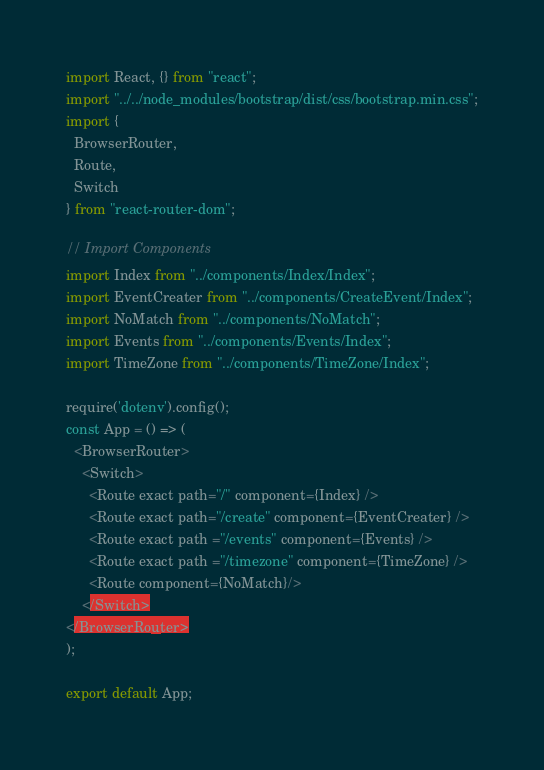<code> <loc_0><loc_0><loc_500><loc_500><_JavaScript_>import React, {} from "react";
import "../../node_modules/bootstrap/dist/css/bootstrap.min.css";
import {
  BrowserRouter,
  Route,
  Switch
} from "react-router-dom";

// Import Components
import Index from "../components/Index/Index";
import EventCreater from "../components/CreateEvent/Index";
import NoMatch from "../components/NoMatch";
import Events from "../components/Events/Index";
import TimeZone from "../components/TimeZone/Index";

require('dotenv').config();
const App = () => (
  <BrowserRouter>
    <Switch>
      <Route exact path="/" component={Index} />
      <Route exact path="/create" component={EventCreater} />
      <Route exact path ="/events" component={Events} />
      <Route exact path ="/timezone" component={TimeZone} />
      <Route component={NoMatch}/>           
    </Switch>
</BrowserRouter>
);

export default App;
</code> 